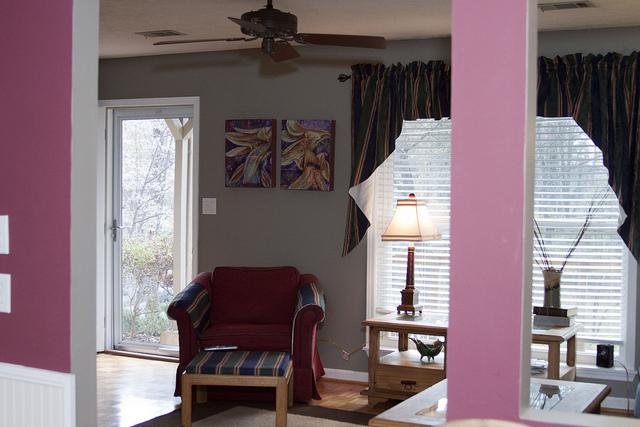Is there a valance over the window?
Keep it brief. Yes. What color are the windows in the back?
Quick response, please. White. What color are the seats?
Give a very brief answer. Red. 